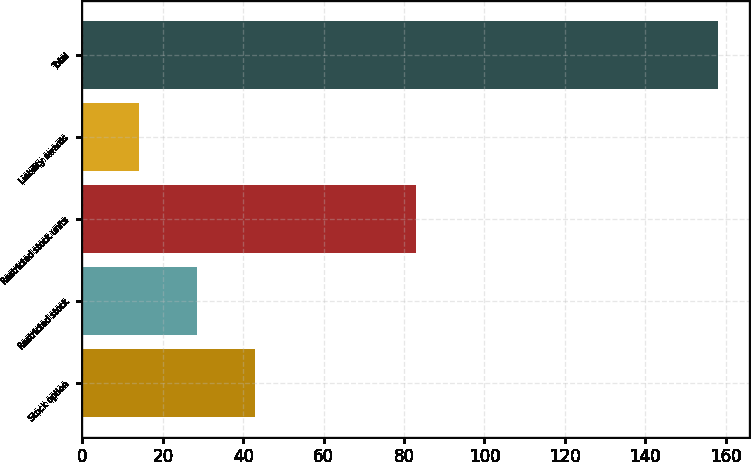<chart> <loc_0><loc_0><loc_500><loc_500><bar_chart><fcel>Stock option<fcel>Restricted stock<fcel>Restricted stock units<fcel>Liability awards<fcel>Total<nl><fcel>42.8<fcel>28.4<fcel>83<fcel>14<fcel>158<nl></chart> 